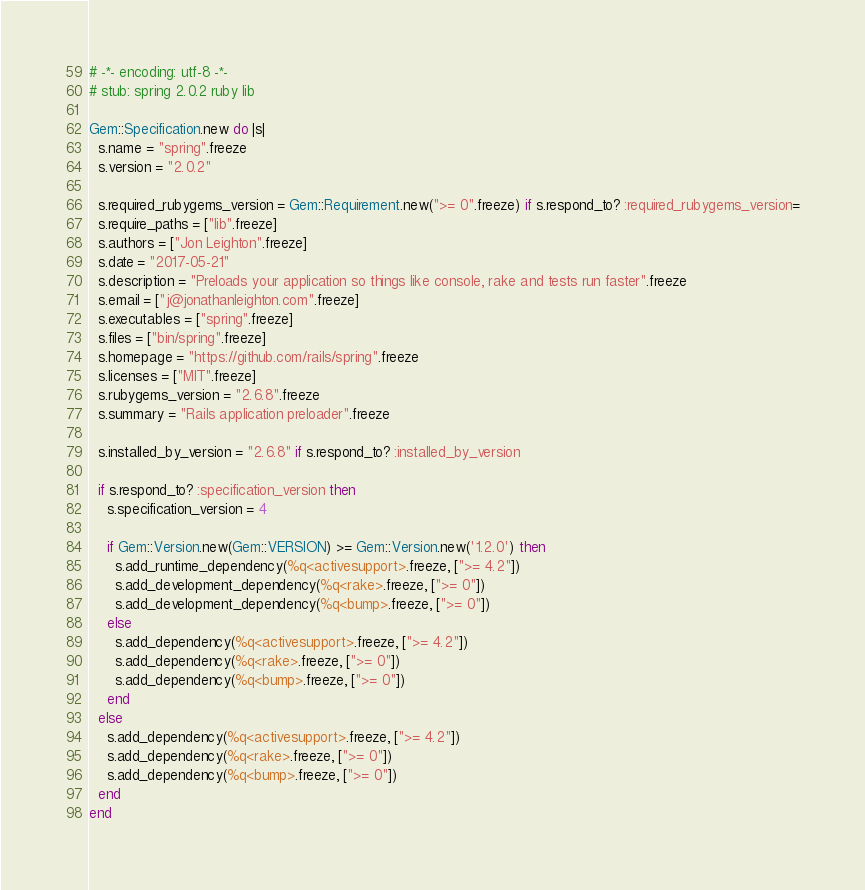<code> <loc_0><loc_0><loc_500><loc_500><_Ruby_># -*- encoding: utf-8 -*-
# stub: spring 2.0.2 ruby lib

Gem::Specification.new do |s|
  s.name = "spring".freeze
  s.version = "2.0.2"

  s.required_rubygems_version = Gem::Requirement.new(">= 0".freeze) if s.respond_to? :required_rubygems_version=
  s.require_paths = ["lib".freeze]
  s.authors = ["Jon Leighton".freeze]
  s.date = "2017-05-21"
  s.description = "Preloads your application so things like console, rake and tests run faster".freeze
  s.email = ["j@jonathanleighton.com".freeze]
  s.executables = ["spring".freeze]
  s.files = ["bin/spring".freeze]
  s.homepage = "https://github.com/rails/spring".freeze
  s.licenses = ["MIT".freeze]
  s.rubygems_version = "2.6.8".freeze
  s.summary = "Rails application preloader".freeze

  s.installed_by_version = "2.6.8" if s.respond_to? :installed_by_version

  if s.respond_to? :specification_version then
    s.specification_version = 4

    if Gem::Version.new(Gem::VERSION) >= Gem::Version.new('1.2.0') then
      s.add_runtime_dependency(%q<activesupport>.freeze, [">= 4.2"])
      s.add_development_dependency(%q<rake>.freeze, [">= 0"])
      s.add_development_dependency(%q<bump>.freeze, [">= 0"])
    else
      s.add_dependency(%q<activesupport>.freeze, [">= 4.2"])
      s.add_dependency(%q<rake>.freeze, [">= 0"])
      s.add_dependency(%q<bump>.freeze, [">= 0"])
    end
  else
    s.add_dependency(%q<activesupport>.freeze, [">= 4.2"])
    s.add_dependency(%q<rake>.freeze, [">= 0"])
    s.add_dependency(%q<bump>.freeze, [">= 0"])
  end
end
</code> 